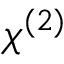Convert formula to latex. <formula><loc_0><loc_0><loc_500><loc_500>\chi ^ { ( 2 ) }</formula> 